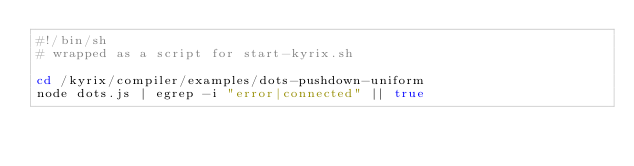Convert code to text. <code><loc_0><loc_0><loc_500><loc_500><_Bash_>#!/bin/sh
# wrapped as a script for start-kyrix.sh

cd /kyrix/compiler/examples/dots-pushdown-uniform
node dots.js | egrep -i "error|connected" || true
</code> 